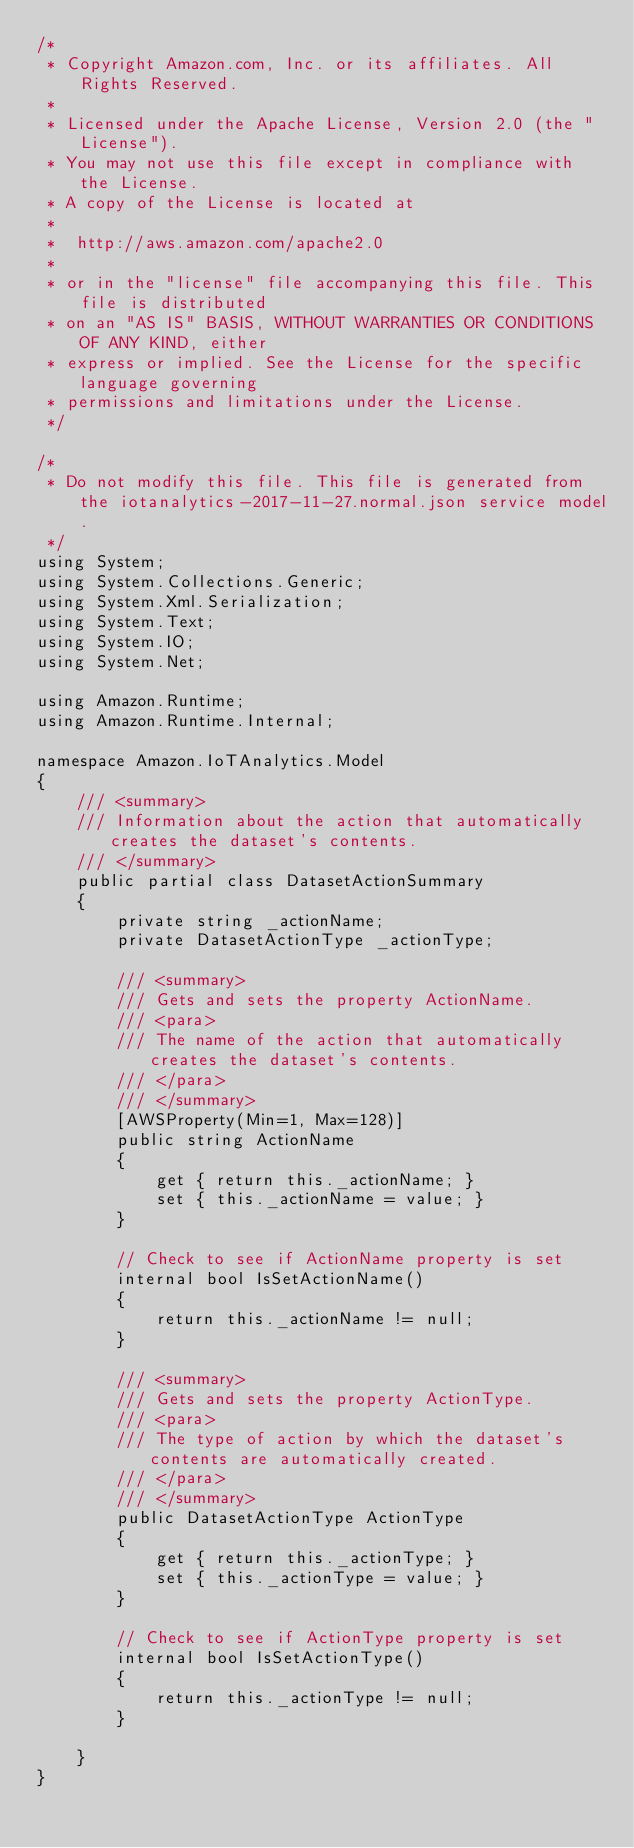Convert code to text. <code><loc_0><loc_0><loc_500><loc_500><_C#_>/*
 * Copyright Amazon.com, Inc. or its affiliates. All Rights Reserved.
 * 
 * Licensed under the Apache License, Version 2.0 (the "License").
 * You may not use this file except in compliance with the License.
 * A copy of the License is located at
 * 
 *  http://aws.amazon.com/apache2.0
 * 
 * or in the "license" file accompanying this file. This file is distributed
 * on an "AS IS" BASIS, WITHOUT WARRANTIES OR CONDITIONS OF ANY KIND, either
 * express or implied. See the License for the specific language governing
 * permissions and limitations under the License.
 */

/*
 * Do not modify this file. This file is generated from the iotanalytics-2017-11-27.normal.json service model.
 */
using System;
using System.Collections.Generic;
using System.Xml.Serialization;
using System.Text;
using System.IO;
using System.Net;

using Amazon.Runtime;
using Amazon.Runtime.Internal;

namespace Amazon.IoTAnalytics.Model
{
    /// <summary>
    /// Information about the action that automatically creates the dataset's contents.
    /// </summary>
    public partial class DatasetActionSummary
    {
        private string _actionName;
        private DatasetActionType _actionType;

        /// <summary>
        /// Gets and sets the property ActionName. 
        /// <para>
        /// The name of the action that automatically creates the dataset's contents.
        /// </para>
        /// </summary>
        [AWSProperty(Min=1, Max=128)]
        public string ActionName
        {
            get { return this._actionName; }
            set { this._actionName = value; }
        }

        // Check to see if ActionName property is set
        internal bool IsSetActionName()
        {
            return this._actionName != null;
        }

        /// <summary>
        /// Gets and sets the property ActionType. 
        /// <para>
        /// The type of action by which the dataset's contents are automatically created.
        /// </para>
        /// </summary>
        public DatasetActionType ActionType
        {
            get { return this._actionType; }
            set { this._actionType = value; }
        }

        // Check to see if ActionType property is set
        internal bool IsSetActionType()
        {
            return this._actionType != null;
        }

    }
}</code> 